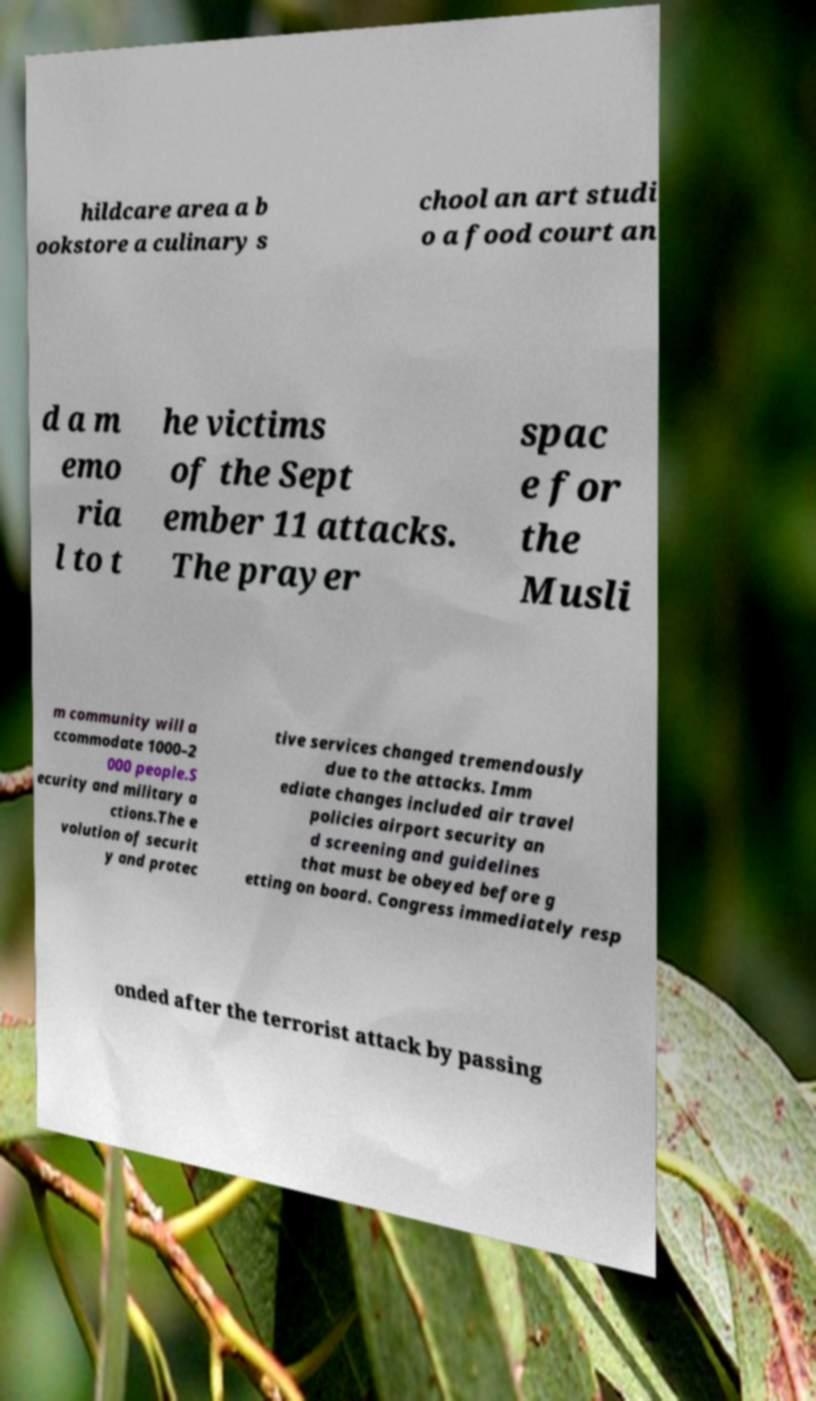Can you accurately transcribe the text from the provided image for me? hildcare area a b ookstore a culinary s chool an art studi o a food court an d a m emo ria l to t he victims of the Sept ember 11 attacks. The prayer spac e for the Musli m community will a ccommodate 1000–2 000 people.S ecurity and military a ctions.The e volution of securit y and protec tive services changed tremendously due to the attacks. Imm ediate changes included air travel policies airport security an d screening and guidelines that must be obeyed before g etting on board. Congress immediately resp onded after the terrorist attack by passing 